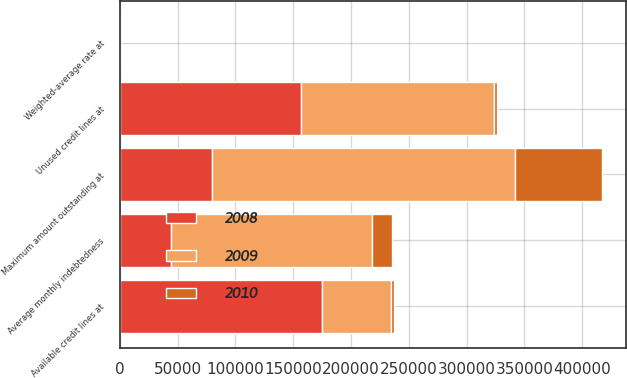<chart> <loc_0><loc_0><loc_500><loc_500><stacked_bar_chart><ecel><fcel>Available credit lines at<fcel>Unused credit lines at<fcel>Maximum amount outstanding at<fcel>Average monthly indebtedness<fcel>Weighted-average rate at<nl><fcel>2010<fcel>2500<fcel>2500<fcel>75403<fcel>17241<fcel>4.5<nl><fcel>2008<fcel>175000<fcel>157000<fcel>79422<fcel>44522<fcel>4.29<nl><fcel>2009<fcel>59962.5<fcel>167000<fcel>262000<fcel>174000<fcel>0.95<nl></chart> 